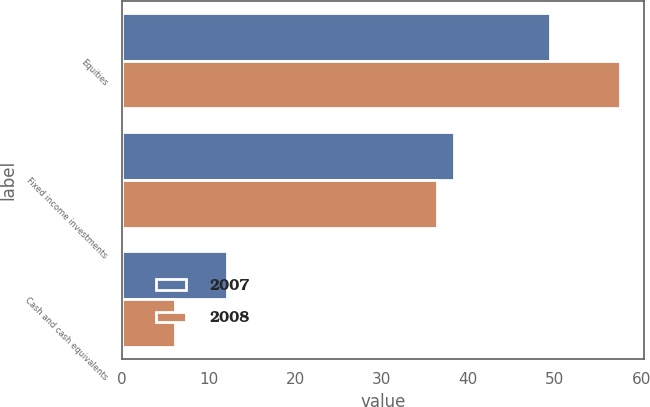Convert chart. <chart><loc_0><loc_0><loc_500><loc_500><stacked_bar_chart><ecel><fcel>Equities<fcel>Fixed income investments<fcel>Cash and cash equivalents<nl><fcel>2007<fcel>49.5<fcel>38.4<fcel>12.1<nl><fcel>2008<fcel>57.5<fcel>36.4<fcel>6.1<nl></chart> 